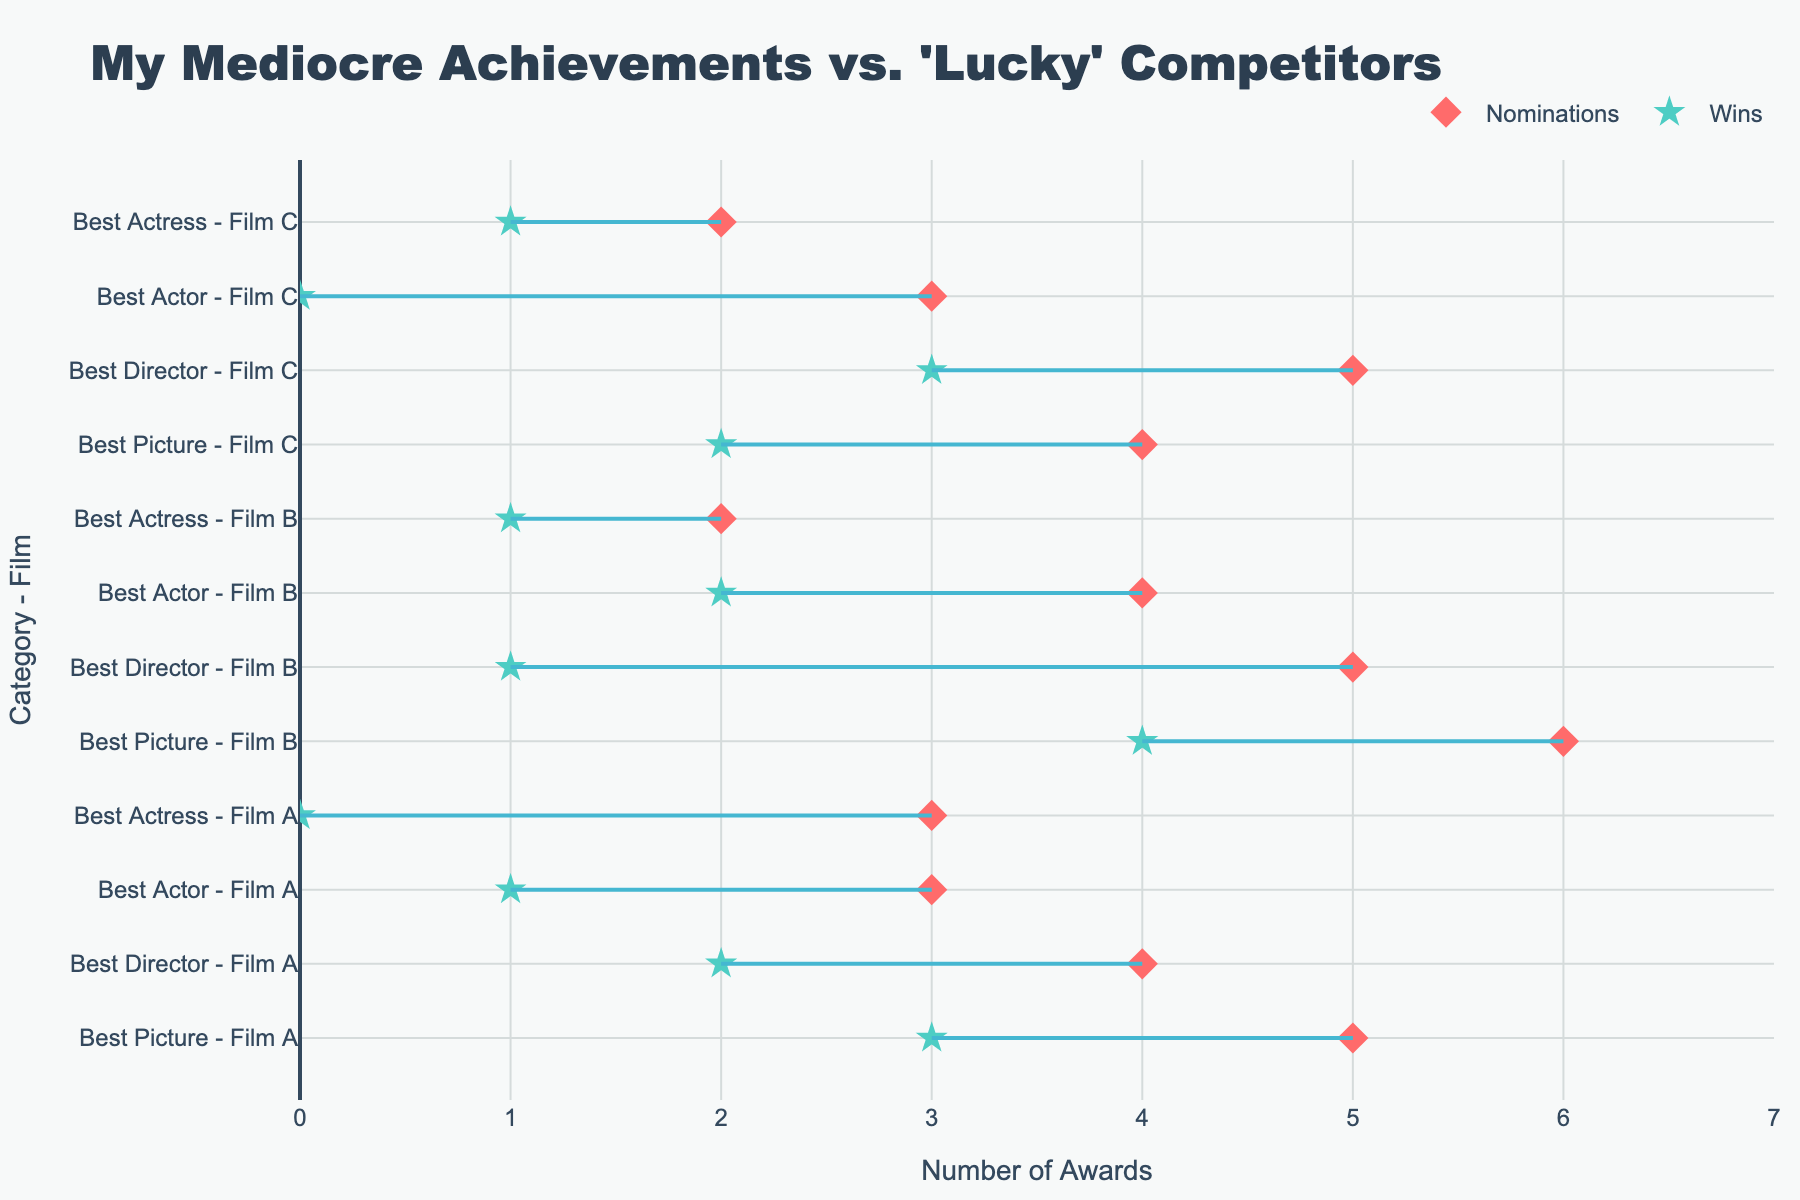What is the title of the plot? The title is always at the top of the plot and appears in a larger, bold font. It reads "My Mediocre Achievements vs. 'Lucky' Competitors".
Answer: My Mediocre Achievements vs. 'Lucky' Competitors What axis shows the number of awards? The x-axis of the plot, which runs horizontally, is titled "Number of Awards". This indicates that the scale along this axis represents the number of awards.
Answer: x-axis How many films are represented in the plot? The y-axis shows different categories for each film. By counting these categories and seeing which films they belong to, we can identify 3 unique films (Film A, Film B, and Film C).
Answer: 3 Which category for Film A has the highest number of nominations? For Film A, we look at the red diamond markers (nominations) on the x-axis. The category with the highest nominated value for Film A is "Best Picture" with 5 nominations.
Answer: Best Picture How many awards did Film B win for the 'Best Director' category? We find Film B in the 'Best Director' category on the y-axis and look at the green star marker (wins) for this row. It shows that Film B won 1 award for the 'Best Director' category.
Answer: 1 For Film C, which category shows an equal number of wins and nominations? We examine Film C's categories and compare the positions of red diamonds and green stars. 'Best Actress' is the only category where the red diamond (nominations) and the green star (wins) both align at 1.
Answer: Best Actress In which category and film do Competitor X have the highest number of awards? Along the y-axis, find instances of Competitor X and track the highest green star marker on the x-axis. For Competitor X, in the category 'Best Picture' of Film B, they have 4 awards.
Answer: Best Picture, Film B What is the total number of nominations across all categories for Film B? Add the nominations (positions of red diamonds) for Film B: 6 (Best Picture) + 5 (Best Director) + 4 (Best Actor) + 2 (Best Actress) = 17.
Answer: 17 Which film and category show the largest discrepancy between nominations and awards? Look for the longest line connecting red diamonds to green stars. The 'Best Director' category for Film B shows the largest gap between 5 nominations and 1 award, a discrepancy of 4.
Answer: Best Director, Film B Which Film A category has the smallest difference between wins and nominations? For Film A, compare the gaps. 'Best Actor' has the smallest difference with 3 nominations and 1 win, making the difference equal to 2.
Answer: Best Actor 